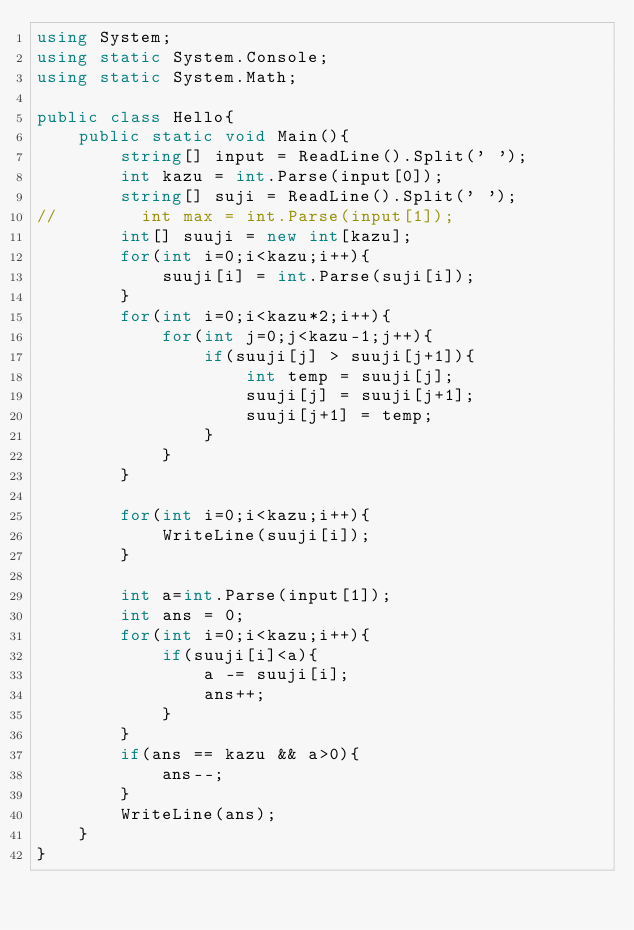Convert code to text. <code><loc_0><loc_0><loc_500><loc_500><_C#_>using System;
using static System.Console;
using static System.Math;

public class Hello{
    public static void Main(){
        string[] input = ReadLine().Split(' ');
        int kazu = int.Parse(input[0]);
        string[] suji = ReadLine().Split(' ');
//        int max = int.Parse(input[1]);
        int[] suuji = new int[kazu];
        for(int i=0;i<kazu;i++){
            suuji[i] = int.Parse(suji[i]);
        }
        for(int i=0;i<kazu*2;i++){
            for(int j=0;j<kazu-1;j++){
                if(suuji[j] > suuji[j+1]){
                    int temp = suuji[j];
                    suuji[j] = suuji[j+1];
                    suuji[j+1] = temp;
                }
            }
        }
        
        for(int i=0;i<kazu;i++){
            WriteLine(suuji[i]);
        }
        
        int a=int.Parse(input[1]);
        int ans = 0;
        for(int i=0;i<kazu;i++){
            if(suuji[i]<a){
                a -= suuji[i];
                ans++;
            }
        }
        if(ans == kazu && a>0){
            ans--;
        }
        WriteLine(ans);
    }
}</code> 